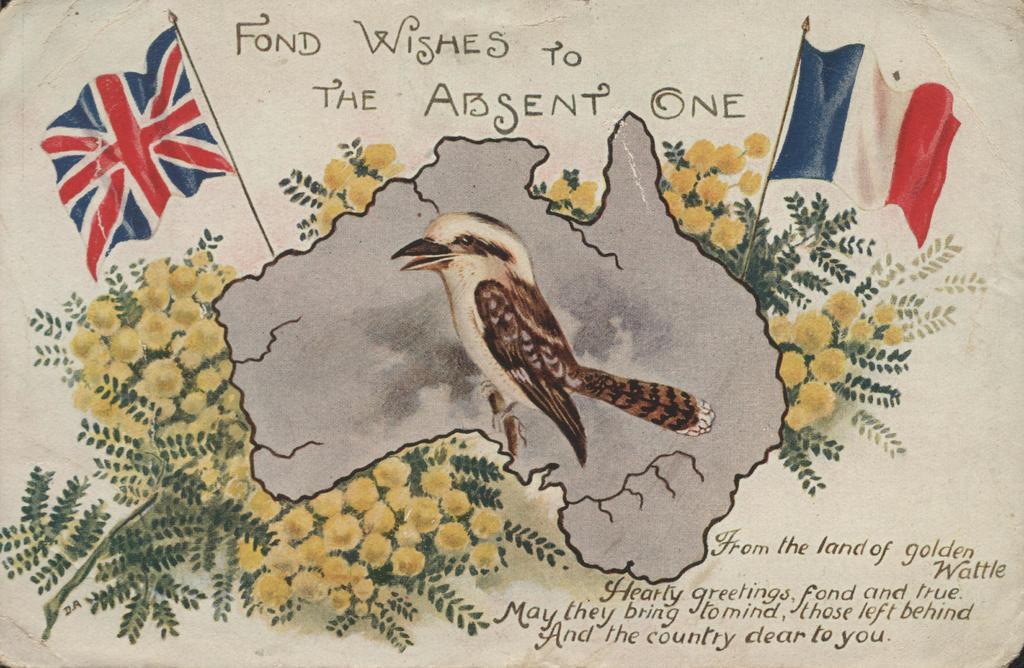Could you give a brief overview of what you see in this image? In this picture we can see art of a bird, flags and flowers, and also we can see some text. 